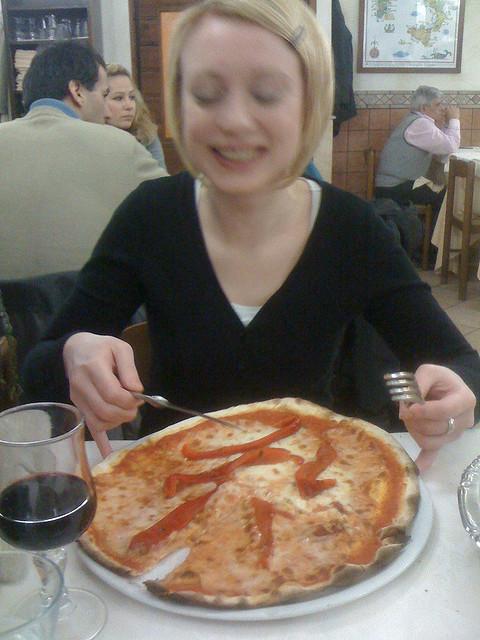What type of wine is shown?
Keep it brief. Red. Is she happy?
Concise answer only. Yes. What is the woman looking at?
Keep it brief. Pizza. How many different types of foods are there?
Keep it brief. 1. What is she drinking?
Give a very brief answer. Wine. What ethnicity is the girl?
Give a very brief answer. White. What type of food is she cutting?
Give a very brief answer. Pizza. How many cups are on the girls right?
Concise answer only. 1. 